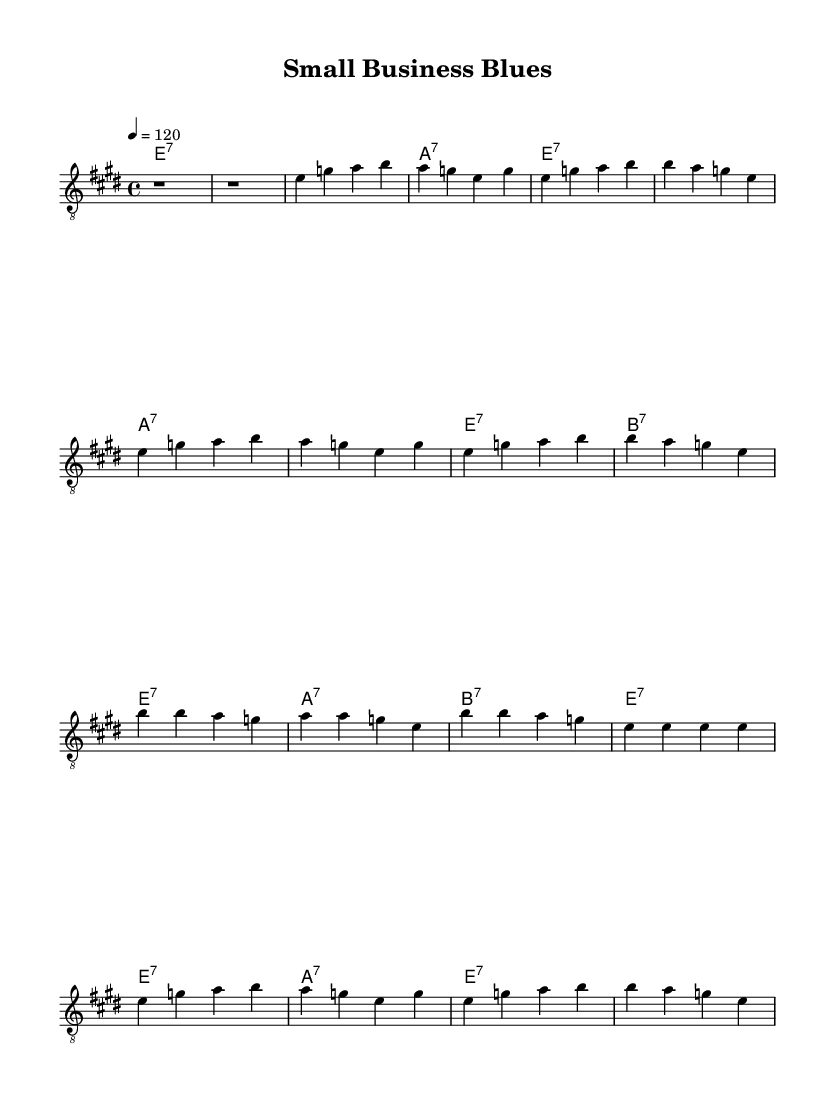What is the key signature of this music? The key signature in the music indicates E major, which has four sharps (F#, C#, G#, D#). This can be identified from the notation typically placed at the beginning of the staff.
Answer: E major What is the time signature of this music? The time signature shown on the sheet is 4/4, which means there are four beats per measure and the quarter note receives one beat. This can be observed on the beginning of the music notations.
Answer: 4/4 What is the tempo marking for this piece? The tempo marking states "4 = 120," which indicates that the quarter note is to be played at a speed of 120 beats per minute. This helps set the pace for the music.
Answer: 120 How many verses are in this composition? The sheet music includes two verses, as indicated by the repeated sections of the music. The first verse is presented in full, and the second verse is abbreviated but still counted as a separate section.
Answer: 2 What chord is played during the chorus? The chord progression for the chorus consists of E7, A7, and B7, focusing on E as the tonic chord throughout this section. The music indicates these chords in the chord line above the staff during the chorus.
Answer: E7, A7, B7 What style of music is being represented in this sheet music? This sheet music represents Electric Blues, characterized by its use of guitar, 4/4 time signature, and a focus on resilience, which relates to small business themes. The phrases and structure align well with typical blues compositions.
Answer: Electric Blues What type of guitar clef is used in this piece? The guitar part is written in treble clef, specifically indicated by the clef sign at the start of the staff. This clef is standard for guitar music and helps to denote higher pitches.
Answer: Treble clef 